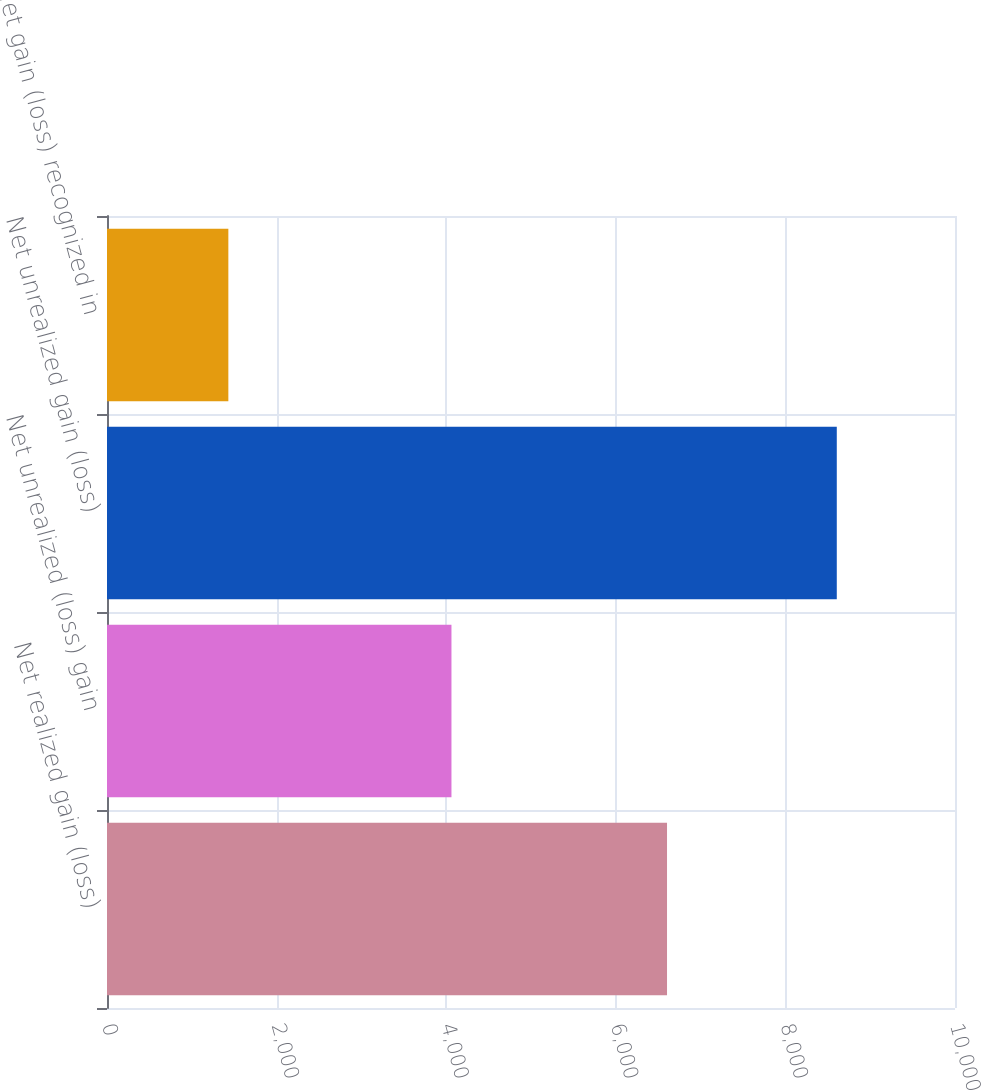Convert chart. <chart><loc_0><loc_0><loc_500><loc_500><bar_chart><fcel>Net realized gain (loss)<fcel>Net unrealized (loss) gain<fcel>Net unrealized gain (loss)<fcel>Net gain (loss) recognized in<nl><fcel>6604<fcel>4062<fcel>8606<fcel>1431<nl></chart> 